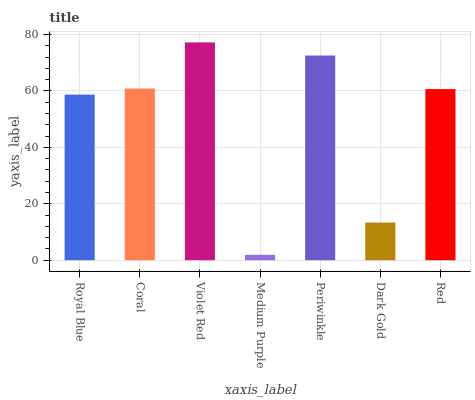Is Coral the minimum?
Answer yes or no. No. Is Coral the maximum?
Answer yes or no. No. Is Coral greater than Royal Blue?
Answer yes or no. Yes. Is Royal Blue less than Coral?
Answer yes or no. Yes. Is Royal Blue greater than Coral?
Answer yes or no. No. Is Coral less than Royal Blue?
Answer yes or no. No. Is Red the high median?
Answer yes or no. Yes. Is Red the low median?
Answer yes or no. Yes. Is Medium Purple the high median?
Answer yes or no. No. Is Royal Blue the low median?
Answer yes or no. No. 